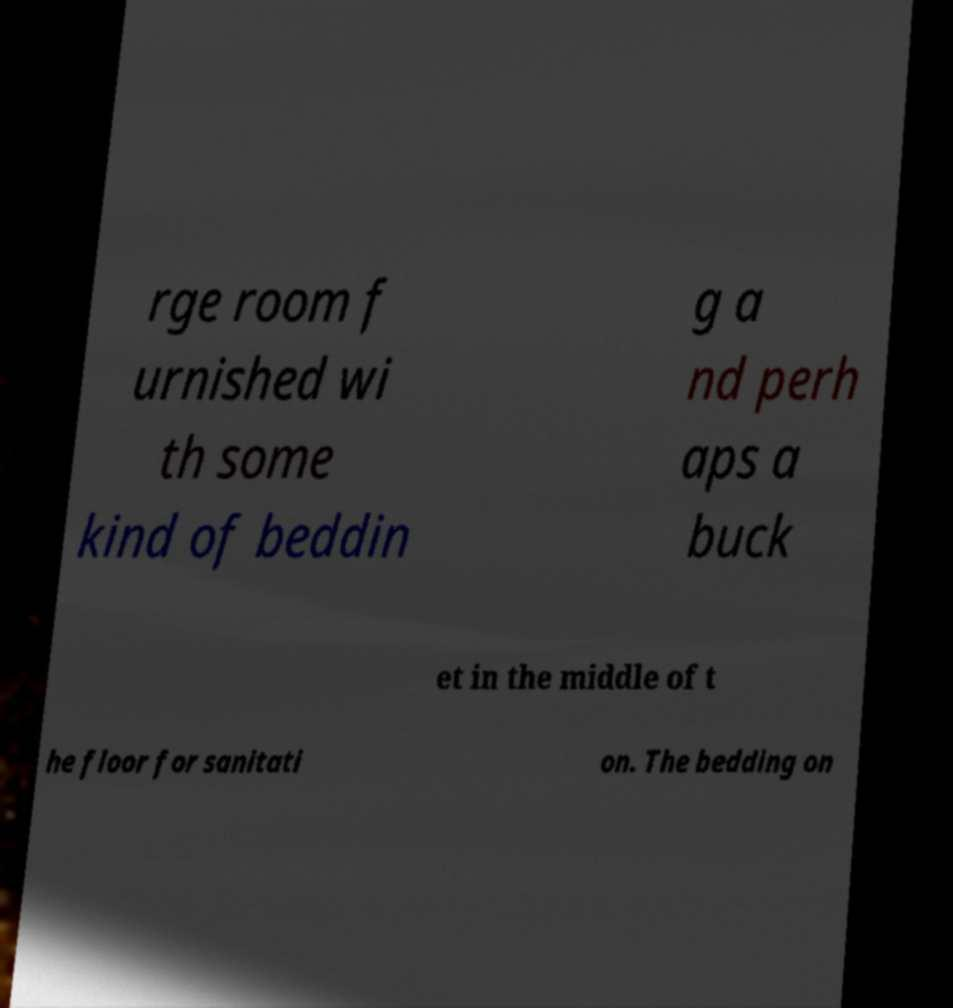What messages or text are displayed in this image? I need them in a readable, typed format. rge room f urnished wi th some kind of beddin g a nd perh aps a buck et in the middle of t he floor for sanitati on. The bedding on 